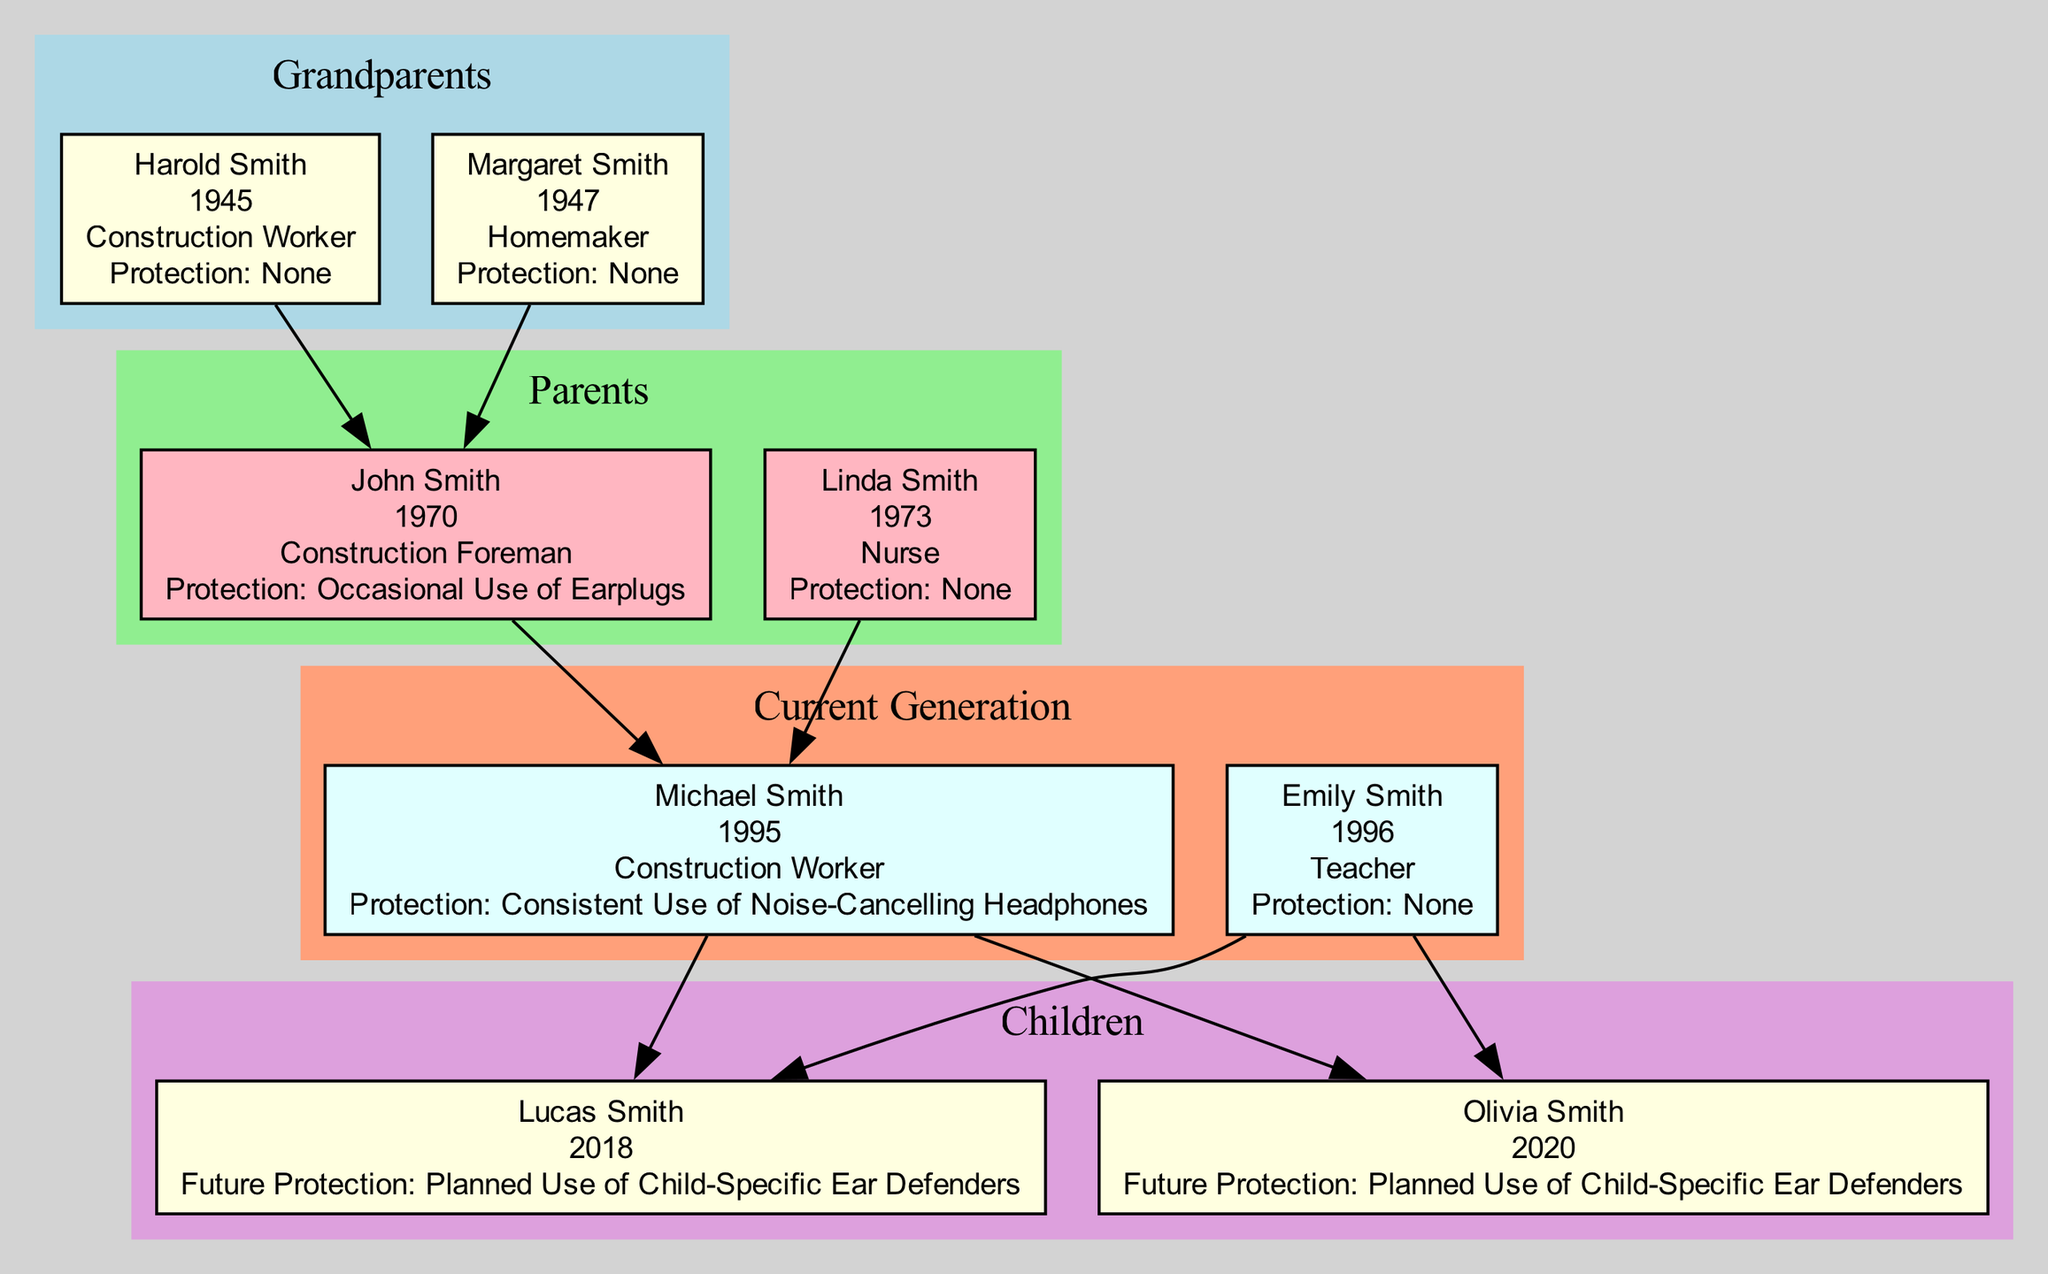What is the profession of Harold Smith? The diagram lists Harold Smith as a "Construction Worker" under the Grandparents section.
Answer: Construction Worker How many children does Michael Smith have? The diagram indicates that Michael Smith has two children, Lucas and Olivia.
Answer: 2 What hearing protection practices did John Smith adopt? John Smith's hearing protection practices are described as "Occasional Use of Earplugs" in the Parents section of the diagram.
Answer: Occasional Use of Earplugs Who is the matriarch of the family? The diagram identifies Margaret Smith as the matriarch in the Grandparents section.
Answer: Margaret Smith What is the future hearing protection practice planned for Olivia Smith? The diagram states that Olivia Smith's future hearing protection practice is "Planned Use of Child-Specific Ear Defenders."
Answer: Planned Use of Child-Specific Ear Defenders Which profession does Linda Smith have? The diagram shows that Linda Smith is a "Nurse" under the Parents section.
Answer: Nurse How many generations are represented in the diagram? The diagram includes three generations: Grandparents, Parents, and Current Generation.
Answer: 3 What relationship does Lucas have to Michael Smith? Lucas Smith is the child of Michael Smith, as illustrated by the edges connecting them in the Current Generation section.
Answer: Child What is the primary change in hearing protection practices from the Grandparents to the Current Generation? The diagram highlights a progression from "None" in the Grandparents' practices to "Consistent Use of Noise-Cancelling Headphones" in the Current Generation, indicating an increased awareness and adaptation.
Answer: Consistent Use of Noise-Cancelling Headphones 